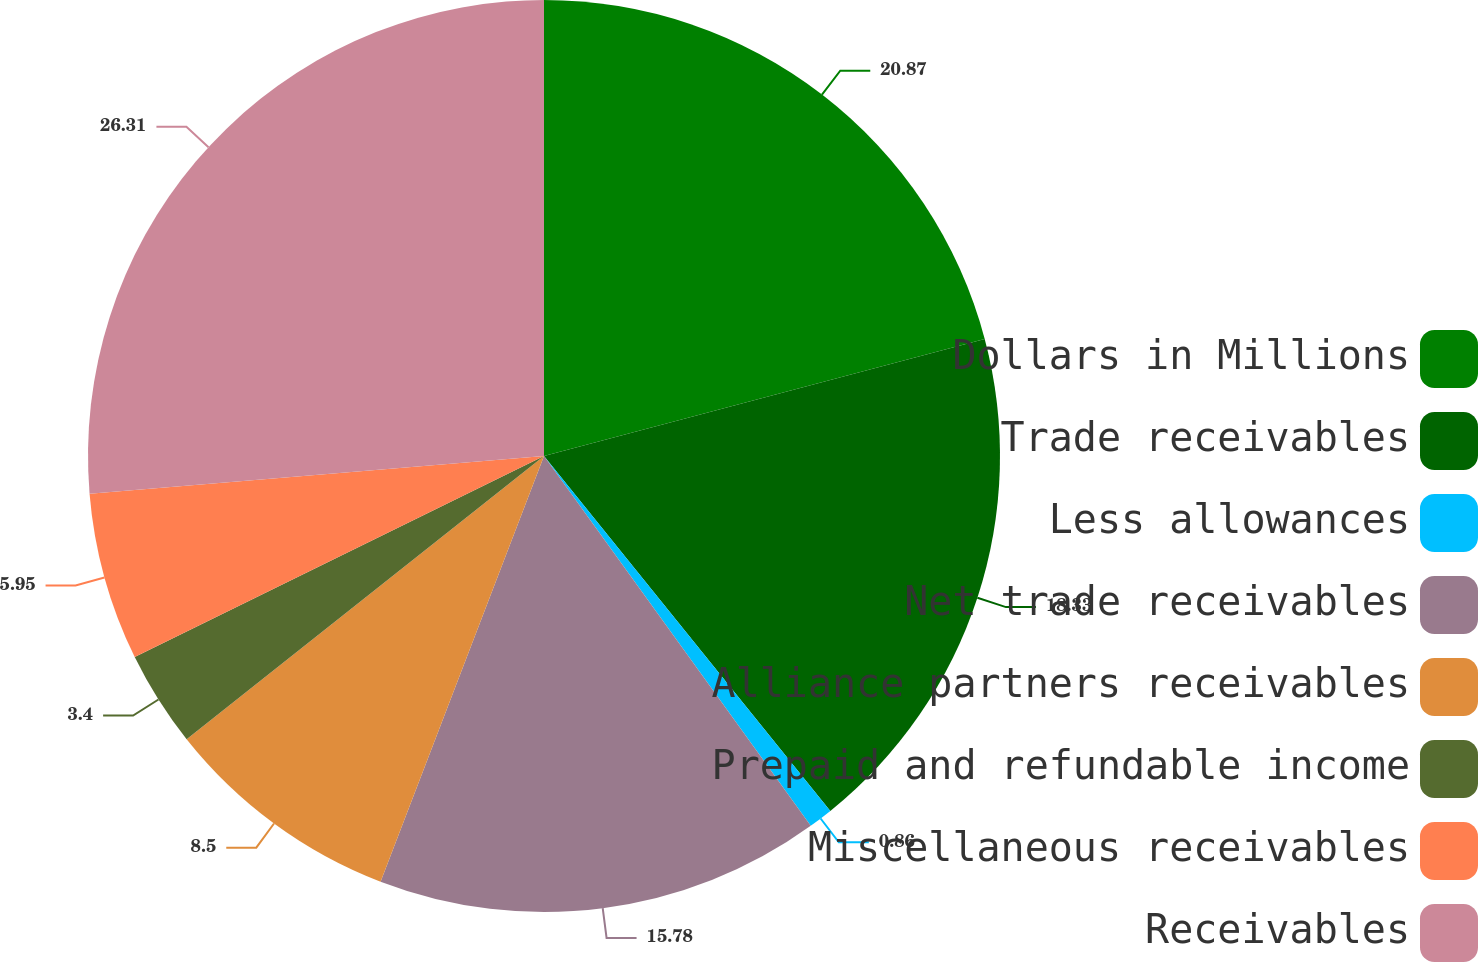Convert chart to OTSL. <chart><loc_0><loc_0><loc_500><loc_500><pie_chart><fcel>Dollars in Millions<fcel>Trade receivables<fcel>Less allowances<fcel>Net trade receivables<fcel>Alliance partners receivables<fcel>Prepaid and refundable income<fcel>Miscellaneous receivables<fcel>Receivables<nl><fcel>20.87%<fcel>18.33%<fcel>0.86%<fcel>15.78%<fcel>8.5%<fcel>3.4%<fcel>5.95%<fcel>26.32%<nl></chart> 